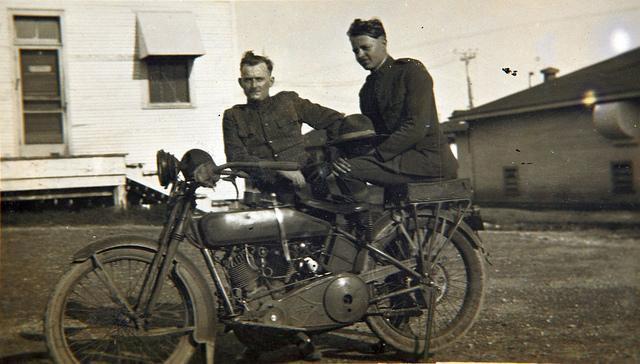How many bikes are there?
Give a very brief answer. 1. How many people in this photo have long hair?
Give a very brief answer. 0. How many people are standing around?
Give a very brief answer. 2. How many seats are on this bike?
Give a very brief answer. 1. How many different types of vehicles are shown?
Give a very brief answer. 1. How many people can you see?
Give a very brief answer. 2. 